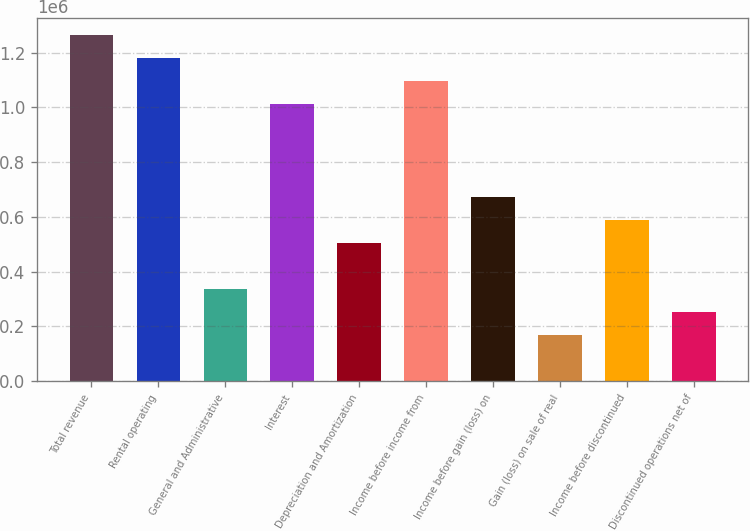<chart> <loc_0><loc_0><loc_500><loc_500><bar_chart><fcel>Total revenue<fcel>Rental operating<fcel>General and Administrative<fcel>Interest<fcel>Depreciation and Amortization<fcel>Income before income from<fcel>Income before gain (loss) on<fcel>Gain (loss) on sale of real<fcel>Income before discontinued<fcel>Discontinued operations net of<nl><fcel>1.26485e+06<fcel>1.18053e+06<fcel>337294<fcel>1.01188e+06<fcel>505941<fcel>1.0962e+06<fcel>674587<fcel>168648<fcel>590264<fcel>252971<nl></chart> 